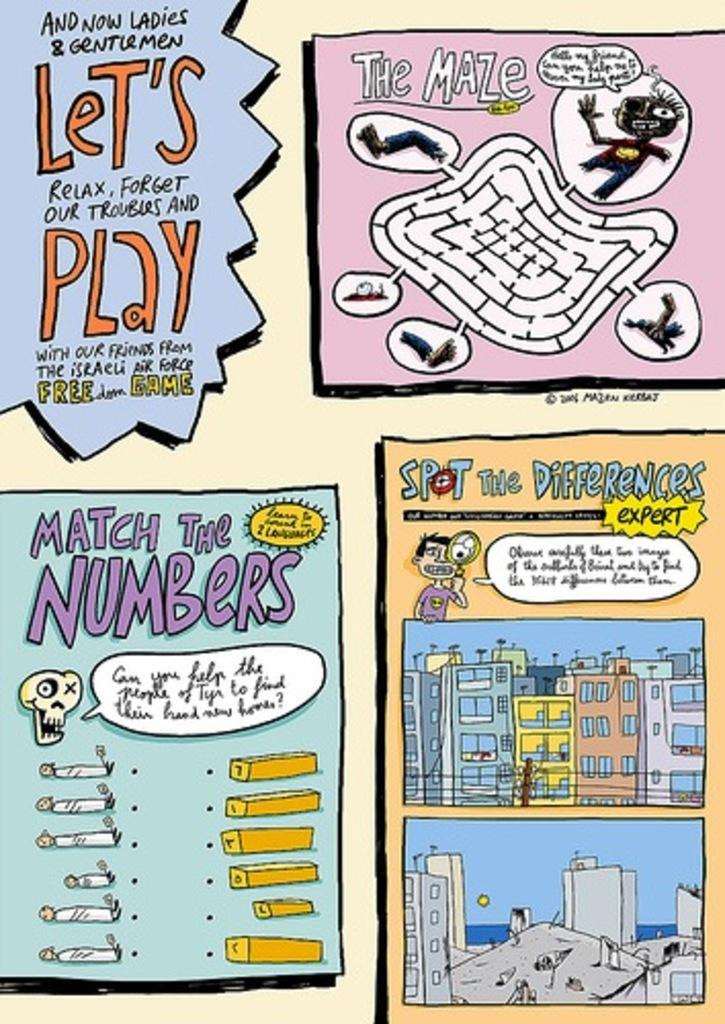What type of objects are present on the posters in the image? The posters contain both text and images. Can you describe the images on the posters? Unfortunately, the specific images on the posters cannot be determined from the provided facts. What is the purpose of the text on the posters? The purpose of the text on the posters cannot be determined from the provided facts. Can you tell me how many tigers are depicted on the posters? There is no mention of tigers in the provided facts, so it cannot be determined if any are depicted on the posters. 